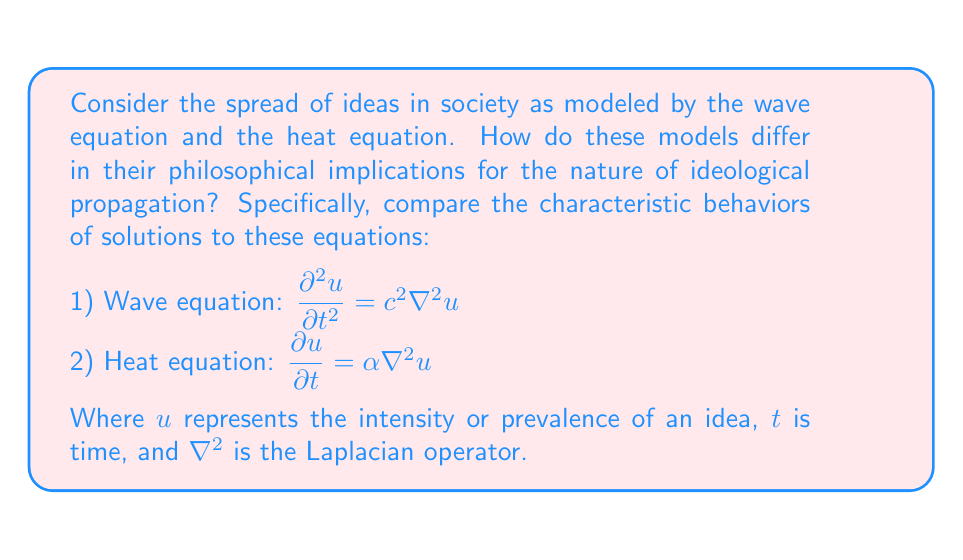Can you solve this math problem? To answer this question, we need to consider the fundamental differences between the wave and heat equations and their philosophical implications:

1) Wave equation behavior:
   - The wave equation is second-order in time ($\frac{\partial^2 u}{\partial t^2}$).
   - Solutions to the wave equation exhibit oscillatory behavior.
   - Ideas modeled by the wave equation would spread with a finite speed $c$.
   - This implies that ideas maintain their "shape" as they propagate.

2) Heat equation behavior:
   - The heat equation is first-order in time ($\frac{\partial u}{\partial t}$).
   - Solutions to the heat equation exhibit diffusive behavior.
   - Ideas modeled by the heat equation would spread with infinite speed.
   - This implies that ideas tend to "smooth out" as they propagate.

Philosophical implications:

a) Nature of ideological change:
   - Wave equation: Suggests ideas spread cyclically, with periods of popularity followed by decline.
   - Heat equation: Suggests ideas spread gradually, becoming more uniform over time.

b) Speed of idea propagation:
   - Wave equation: Implies a limit to how fast ideas can spread (speed $c$).
   - Heat equation: Suggests instantaneous (though weak) influence over large distances.

c) Preservation of original form:
   - Wave equation: Ideas maintain their original "shape," preserving distinct characteristics.
   - Heat equation: Ideas blend and lose distinctiveness over time.

d) Reversibility:
   - Wave equation: Theoretically reversible, suggesting ideas could return to their origin unchanged.
   - Heat equation: Irreversible process, implying ideas evolve and cannot return to their exact original state.

These differences suggest fundamentally different views on how ideas propagate and evolve in society, reflecting contrasting philosophical perspectives on the nature of ideological change and cultural evolution.
Answer: The wave equation implies cyclical, bounded-speed idea propagation with preserved distinctiveness, while the heat equation suggests gradual, unbounded-speed diffusion with loss of distinctiveness, representing contrasting philosophical views on ideological evolution in society. 